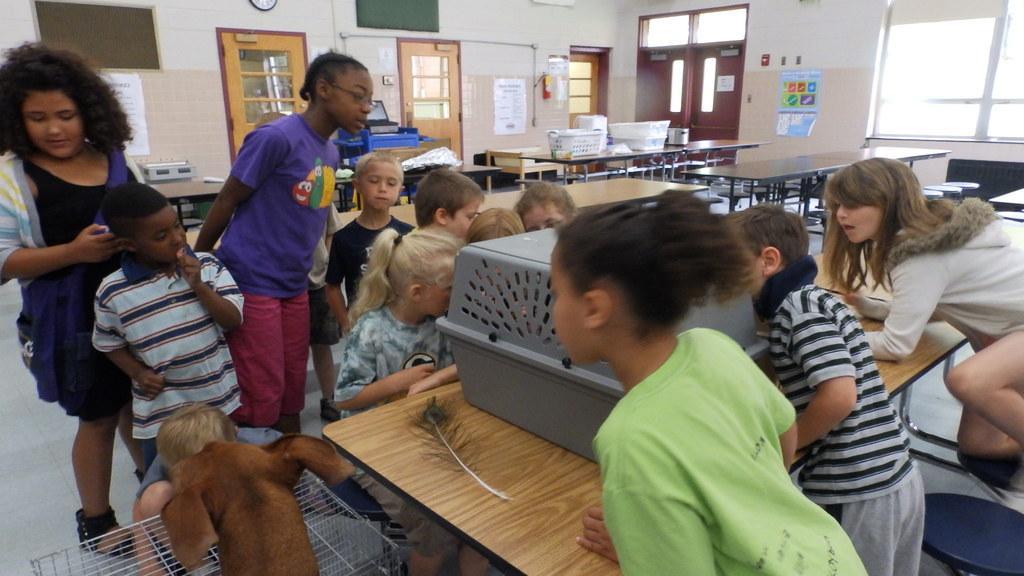Could you give a brief overview of what you see in this image? In the center of the image there are many children. There is a table on which there is a object. In the background of the image there are doors. There is wall. There are many tables in the image. 